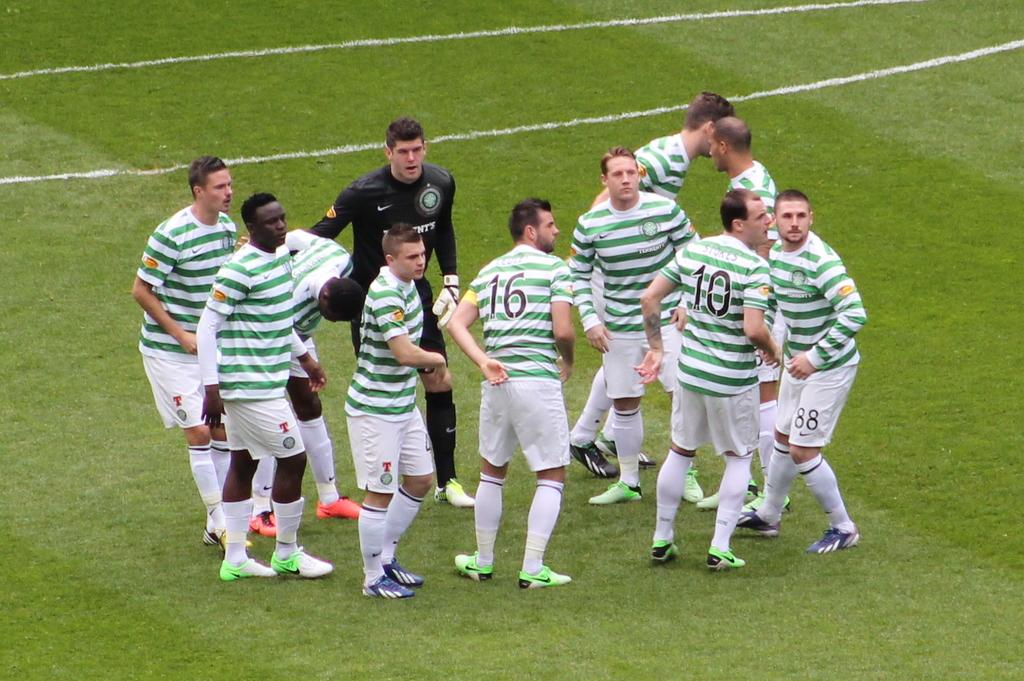<image>
Create a compact narrative representing the image presented. Player number 16 has one of his hands behind his back. 